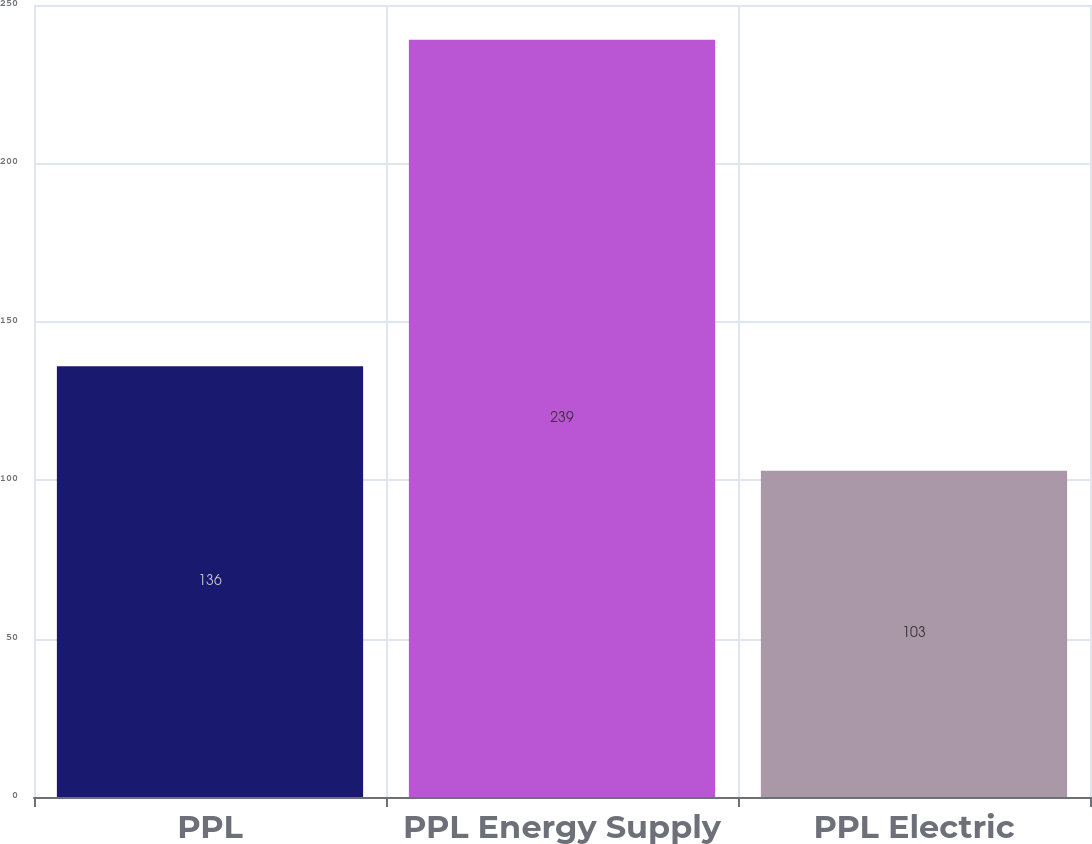<chart> <loc_0><loc_0><loc_500><loc_500><bar_chart><fcel>PPL<fcel>PPL Energy Supply<fcel>PPL Electric<nl><fcel>136<fcel>239<fcel>103<nl></chart> 